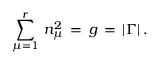<formula> <loc_0><loc_0><loc_500><loc_500>\sum _ { \mu = 1 } ^ { r } \, n _ { \mu } ^ { 2 } \, = \, g \, = \, | \Gamma | \, .</formula> 